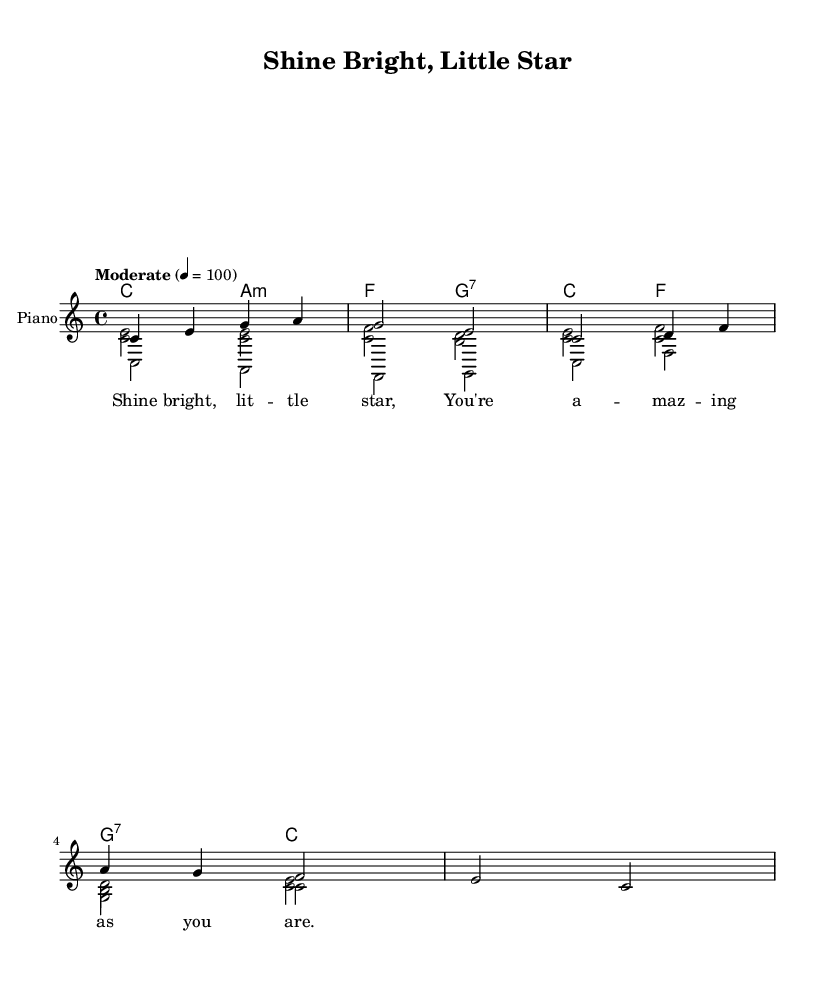What is the key signature of this music? The key signature is indicated at the beginning of the staff. It shows no sharps or flats, which means it is in C major.
Answer: C major What is the time signature of the piece? The time signature is defined at the beginning and shows four beats in each measure, indicated by the number 4 over 4.
Answer: 4/4 What is the tempo marking provided in the sheet music? The tempo marking is located in the header. It indicates a moderate pace with a speed of 100 beats per minute, written as "Moderate" followed by "4 = 100".
Answer: Moderate How many measures are in the melody section? By counting the number of vertical lines separating the musical sections, you find that there are 5 measures in the melody.
Answer: 5 What is the first lyric line of the song? The lyrics are directly below the melody notes in the sheet music. The first line reads: "Shine bright, lit -- tle star".
Answer: Shine bright, lit -- tle star What is the relationship of the harmony to the melody in this piece? The melody is harmonized with chords that support the melody notes. The first chord, C major, is played alongside the first notes of the melody, establishing a foundation; this chord progression continues throughout.
Answer: Chords support the melody 